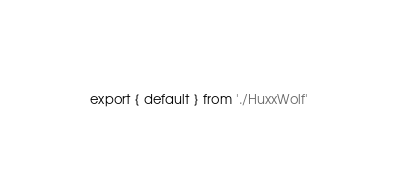Convert code to text. <code><loc_0><loc_0><loc_500><loc_500><_TypeScript_>export { default } from './HuxxWolf'</code> 